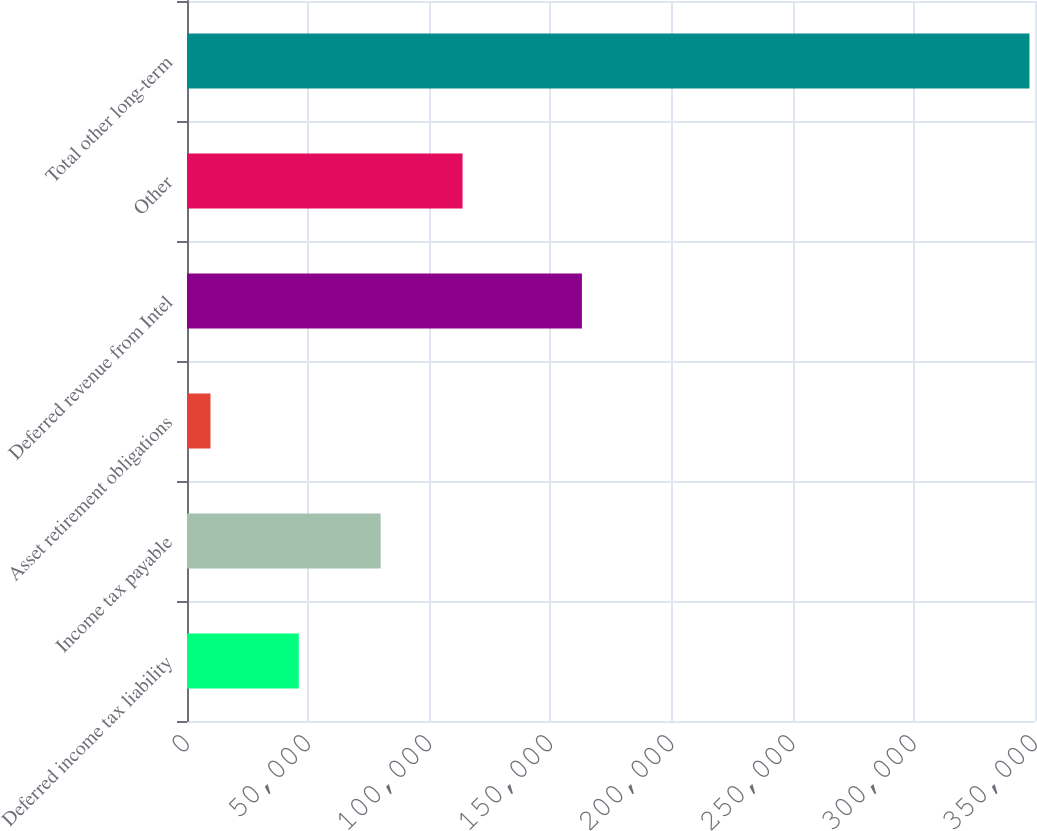Convert chart. <chart><loc_0><loc_0><loc_500><loc_500><bar_chart><fcel>Deferred income tax liability<fcel>Income tax payable<fcel>Asset retirement obligations<fcel>Deferred revenue from Intel<fcel>Other<fcel>Total other long-term<nl><fcel>46129<fcel>79930.9<fcel>9694<fcel>163000<fcel>113733<fcel>347713<nl></chart> 